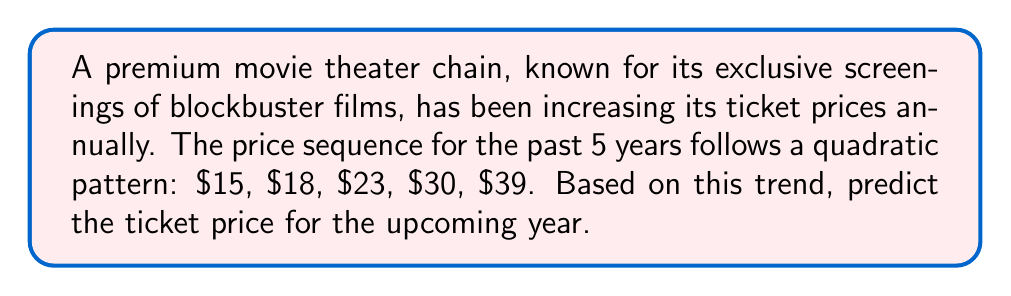Show me your answer to this math problem. To solve this problem, we need to find the quadratic sequence that fits the given data points. Let's approach this step-by-step:

1) The general form of a quadratic sequence is:
   $$a_n = an^2 + bn + c$$
   where $n$ is the term number (starting from 0), and $a$, $b$, and $c$ are constants.

2) We have the following data points:
   $a_0 = 15$
   $a_1 = 18$
   $a_2 = 23$
   $a_3 = 30$
   $a_4 = 39$

3) To find $a$, $b$, and $c$, we can use the method of differences:
   First differences:  3, 5, 7, 9
   Second differences: 2, 2, 2

4) The second difference is constant (2), confirming it's a quadratic sequence. 
   The coefficient $a$ is half of this constant: $a = 2/2 = 1$

5) Now we can set up three equations using the first three terms:
   $15 = c$
   $18 = a + b + c$
   $23 = 4a + 2b + c$

6) Substituting known values:
   $15 = c$
   $18 = 1 + b + 15$
   $23 = 4 + 2b + 15$

7) Solving these equations:
   $c = 15$
   $b = 2$
   $a = 1$

8) Our quadratic sequence is therefore:
   $$a_n = n^2 + 2n + 15$$

9) To predict the next term (year 6), we calculate $a_5$:
   $$a_5 = 5^2 + 2(5) + 15 = 25 + 10 + 15 = 50$$

Therefore, the predicted ticket price for the upcoming year is $50.
Answer: $50 